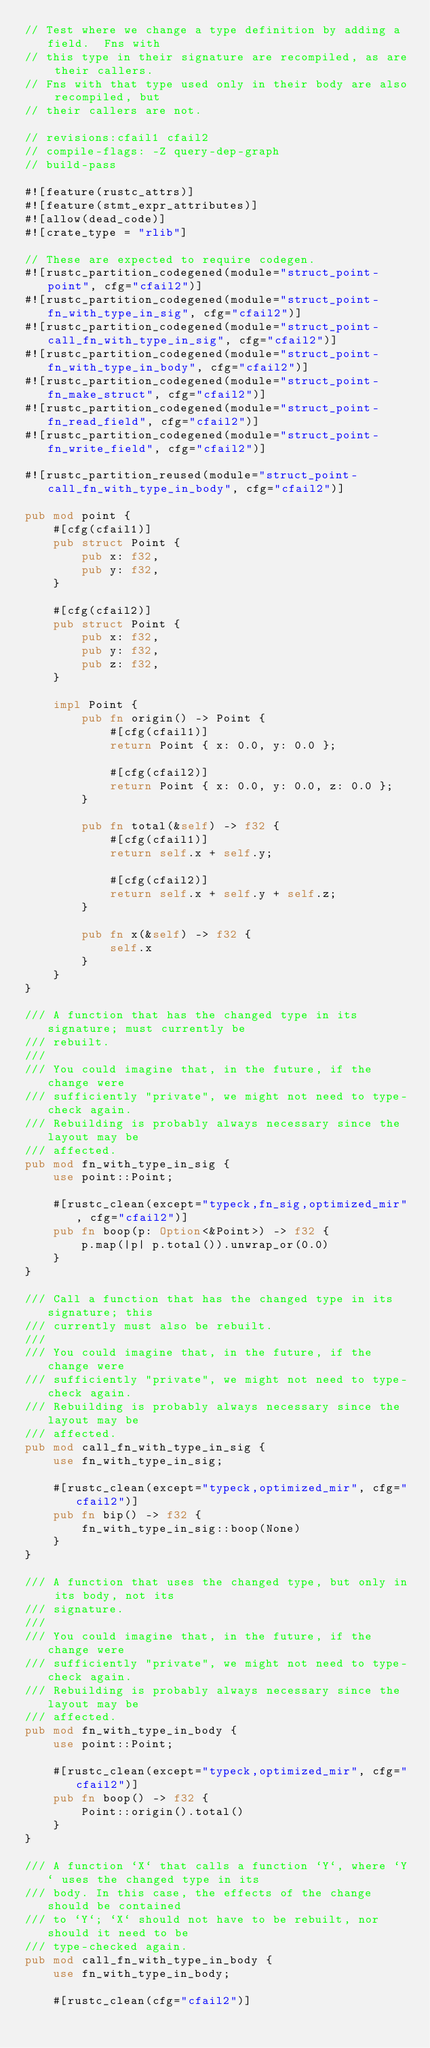Convert code to text. <code><loc_0><loc_0><loc_500><loc_500><_Rust_>// Test where we change a type definition by adding a field.  Fns with
// this type in their signature are recompiled, as are their callers.
// Fns with that type used only in their body are also recompiled, but
// their callers are not.

// revisions:cfail1 cfail2
// compile-flags: -Z query-dep-graph
// build-pass

#![feature(rustc_attrs)]
#![feature(stmt_expr_attributes)]
#![allow(dead_code)]
#![crate_type = "rlib"]

// These are expected to require codegen.
#![rustc_partition_codegened(module="struct_point-point", cfg="cfail2")]
#![rustc_partition_codegened(module="struct_point-fn_with_type_in_sig", cfg="cfail2")]
#![rustc_partition_codegened(module="struct_point-call_fn_with_type_in_sig", cfg="cfail2")]
#![rustc_partition_codegened(module="struct_point-fn_with_type_in_body", cfg="cfail2")]
#![rustc_partition_codegened(module="struct_point-fn_make_struct", cfg="cfail2")]
#![rustc_partition_codegened(module="struct_point-fn_read_field", cfg="cfail2")]
#![rustc_partition_codegened(module="struct_point-fn_write_field", cfg="cfail2")]

#![rustc_partition_reused(module="struct_point-call_fn_with_type_in_body", cfg="cfail2")]

pub mod point {
    #[cfg(cfail1)]
    pub struct Point {
        pub x: f32,
        pub y: f32,
    }

    #[cfg(cfail2)]
    pub struct Point {
        pub x: f32,
        pub y: f32,
        pub z: f32,
    }

    impl Point {
        pub fn origin() -> Point {
            #[cfg(cfail1)]
            return Point { x: 0.0, y: 0.0 };

            #[cfg(cfail2)]
            return Point { x: 0.0, y: 0.0, z: 0.0 };
        }

        pub fn total(&self) -> f32 {
            #[cfg(cfail1)]
            return self.x + self.y;

            #[cfg(cfail2)]
            return self.x + self.y + self.z;
        }

        pub fn x(&self) -> f32 {
            self.x
        }
    }
}

/// A function that has the changed type in its signature; must currently be
/// rebuilt.
///
/// You could imagine that, in the future, if the change were
/// sufficiently "private", we might not need to type-check again.
/// Rebuilding is probably always necessary since the layout may be
/// affected.
pub mod fn_with_type_in_sig {
    use point::Point;

    #[rustc_clean(except="typeck,fn_sig,optimized_mir", cfg="cfail2")]
    pub fn boop(p: Option<&Point>) -> f32 {
        p.map(|p| p.total()).unwrap_or(0.0)
    }
}

/// Call a function that has the changed type in its signature; this
/// currently must also be rebuilt.
///
/// You could imagine that, in the future, if the change were
/// sufficiently "private", we might not need to type-check again.
/// Rebuilding is probably always necessary since the layout may be
/// affected.
pub mod call_fn_with_type_in_sig {
    use fn_with_type_in_sig;

    #[rustc_clean(except="typeck,optimized_mir", cfg="cfail2")]
    pub fn bip() -> f32 {
        fn_with_type_in_sig::boop(None)
    }
}

/// A function that uses the changed type, but only in its body, not its
/// signature.
///
/// You could imagine that, in the future, if the change were
/// sufficiently "private", we might not need to type-check again.
/// Rebuilding is probably always necessary since the layout may be
/// affected.
pub mod fn_with_type_in_body {
    use point::Point;

    #[rustc_clean(except="typeck,optimized_mir", cfg="cfail2")]
    pub fn boop() -> f32 {
        Point::origin().total()
    }
}

/// A function `X` that calls a function `Y`, where `Y` uses the changed type in its
/// body. In this case, the effects of the change should be contained
/// to `Y`; `X` should not have to be rebuilt, nor should it need to be
/// type-checked again.
pub mod call_fn_with_type_in_body {
    use fn_with_type_in_body;

    #[rustc_clean(cfg="cfail2")]</code> 